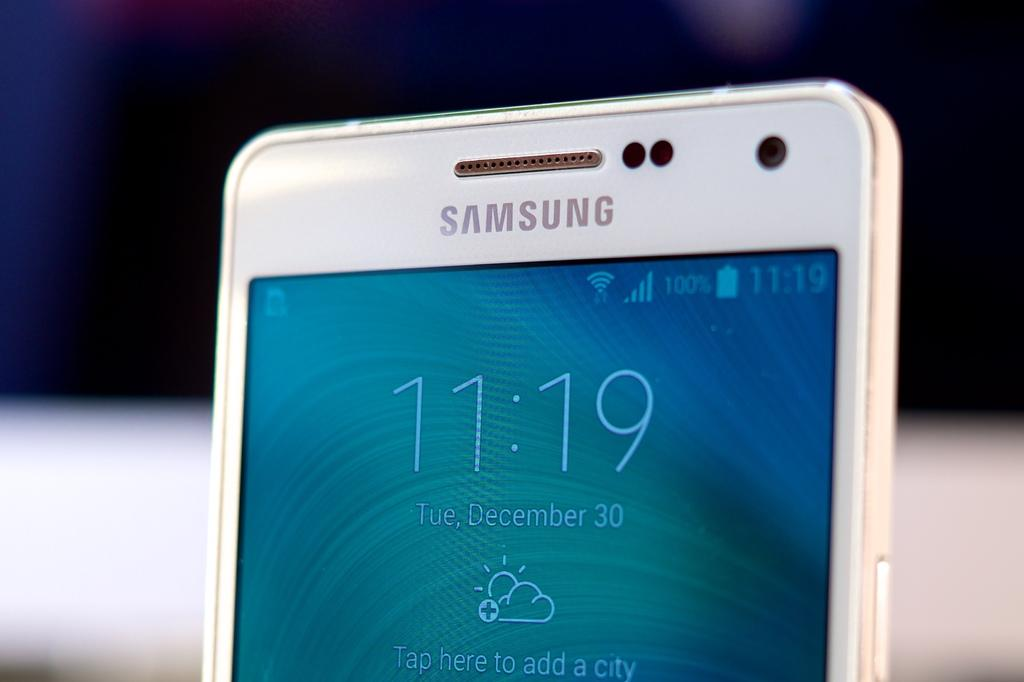<image>
Give a short and clear explanation of the subsequent image. The top half of a Samsung cellphone showing the time, date and weather conditions. 